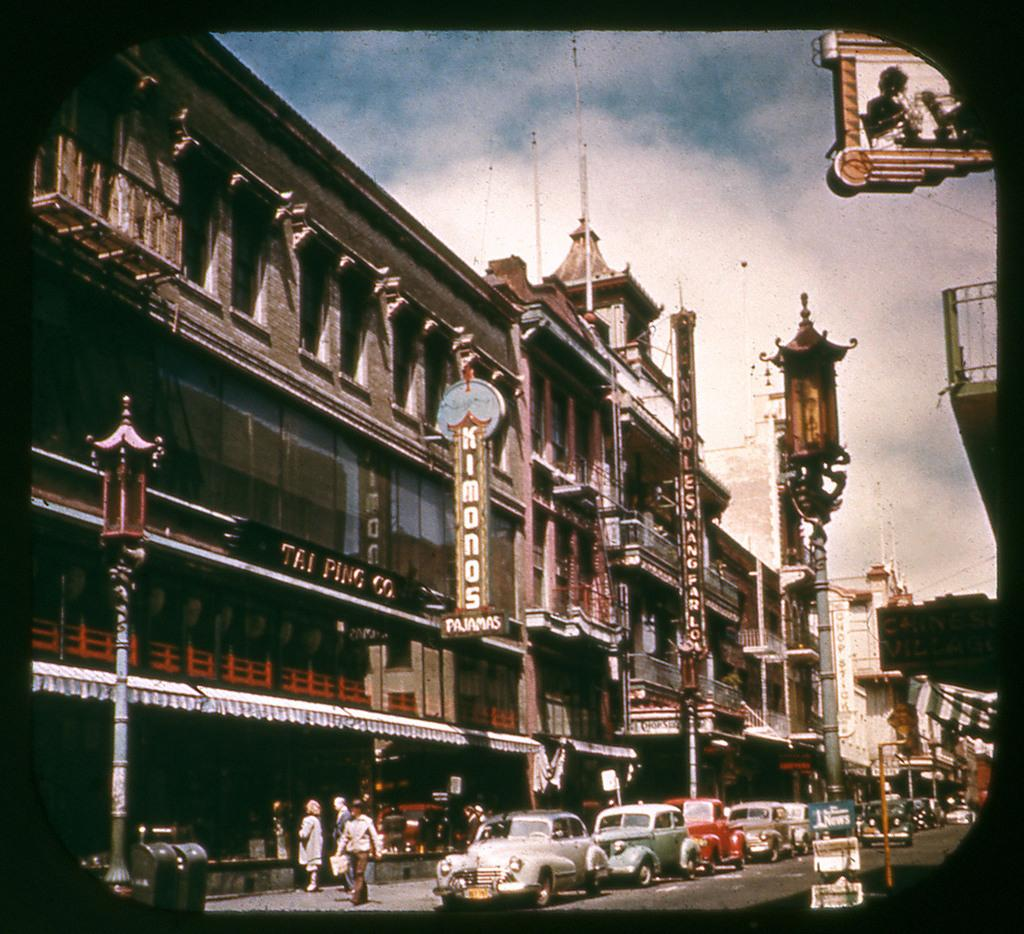Provide a one-sentence caption for the provided image. Several cars are parked in front of the Tai Ping Co. building. 